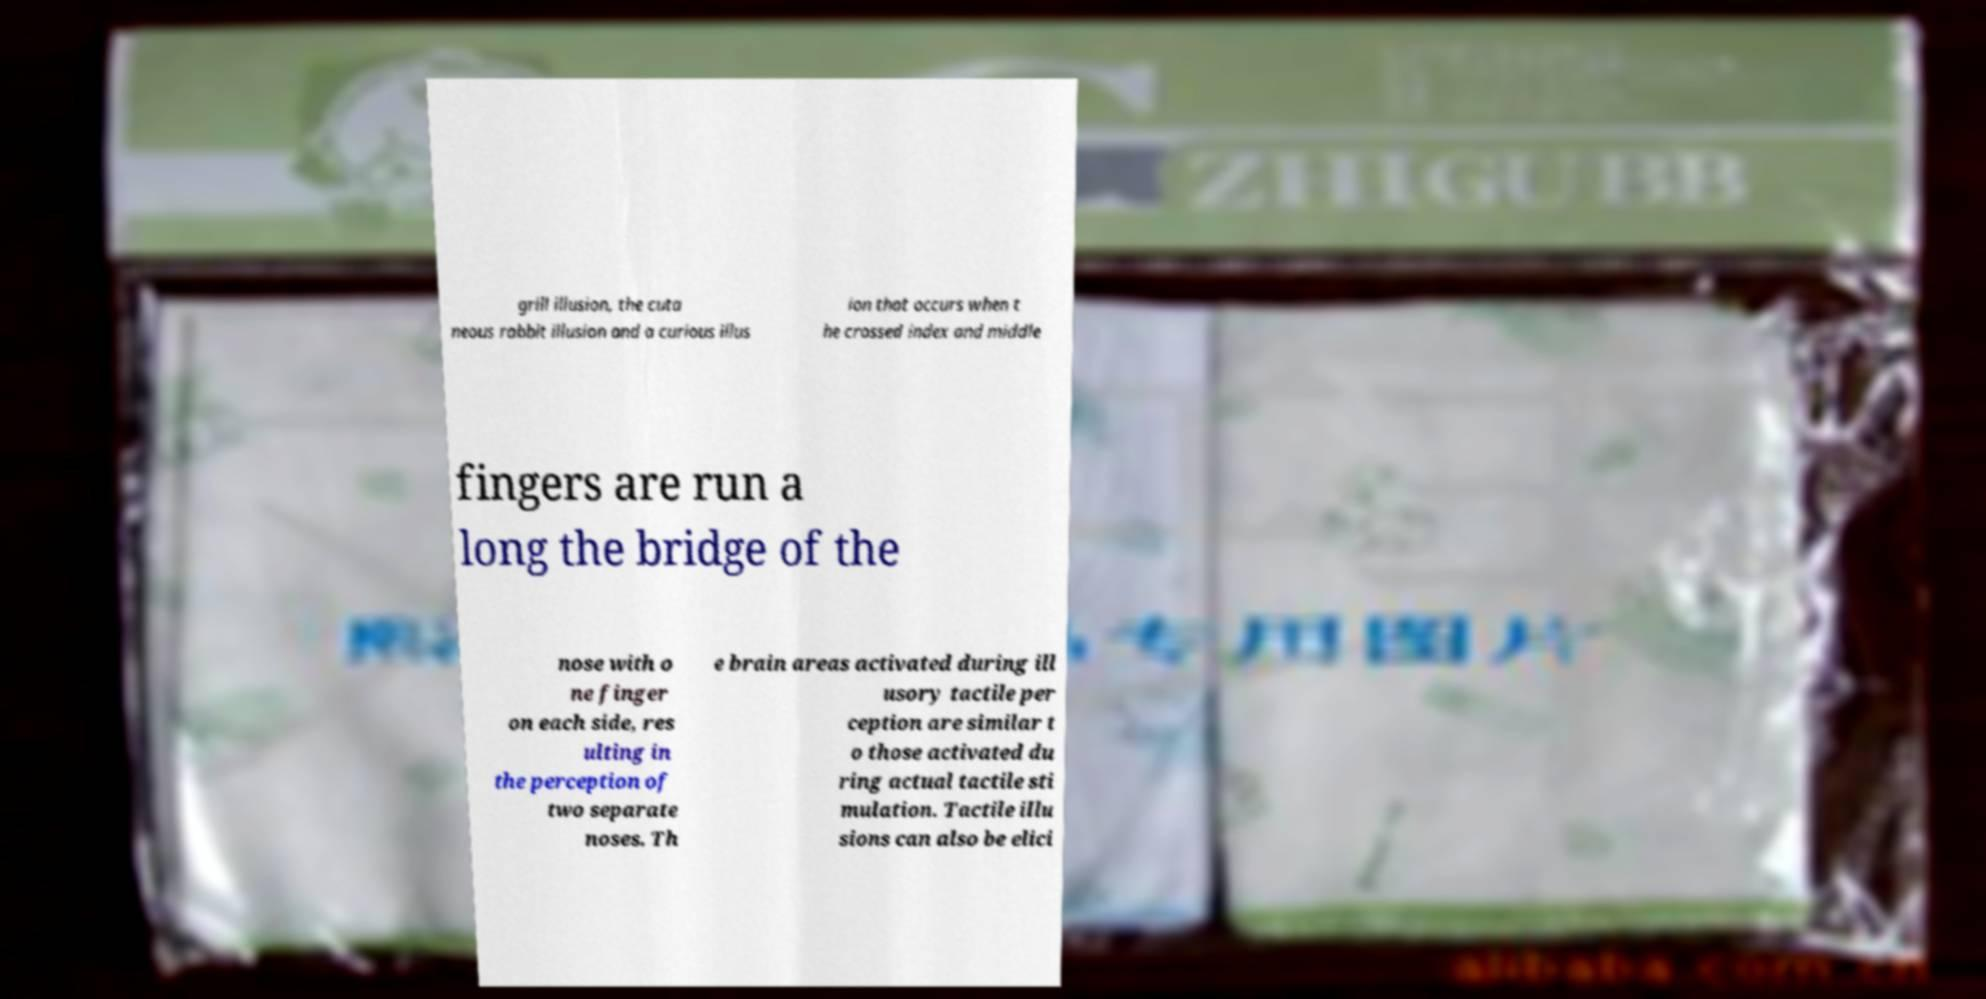Can you read and provide the text displayed in the image?This photo seems to have some interesting text. Can you extract and type it out for me? grill illusion, the cuta neous rabbit illusion and a curious illus ion that occurs when t he crossed index and middle fingers are run a long the bridge of the nose with o ne finger on each side, res ulting in the perception of two separate noses. Th e brain areas activated during ill usory tactile per ception are similar t o those activated du ring actual tactile sti mulation. Tactile illu sions can also be elici 